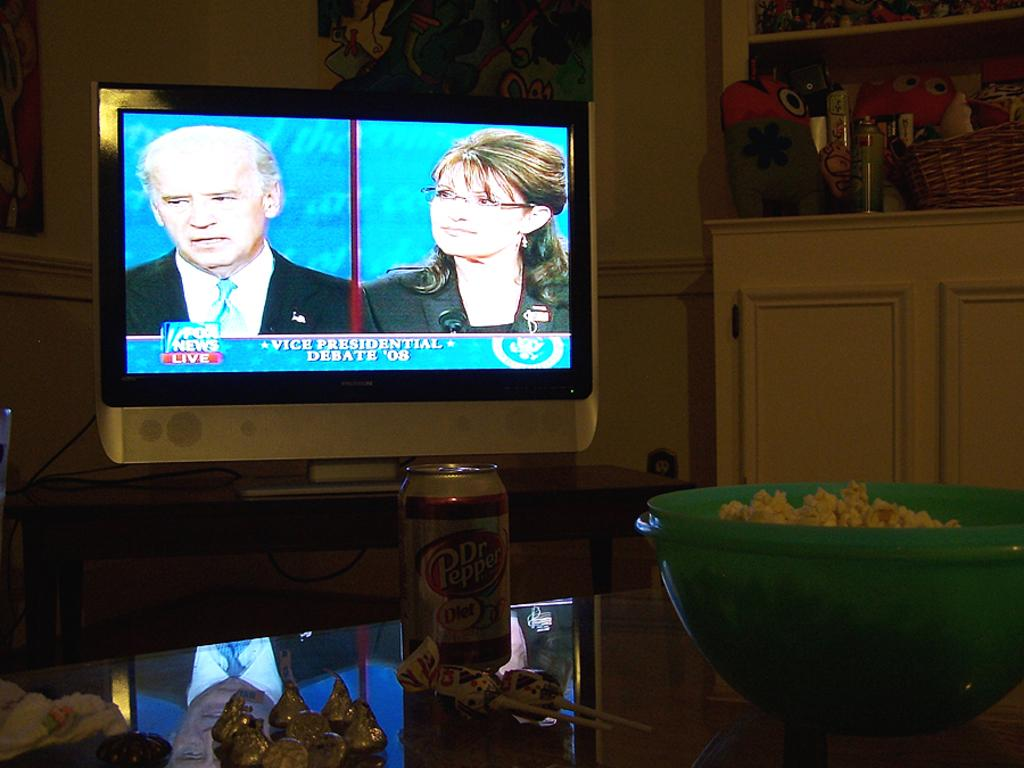Provide a one-sentence caption for the provided image. John is watching the VP debate between Joe Biden and Sarah Palin. 